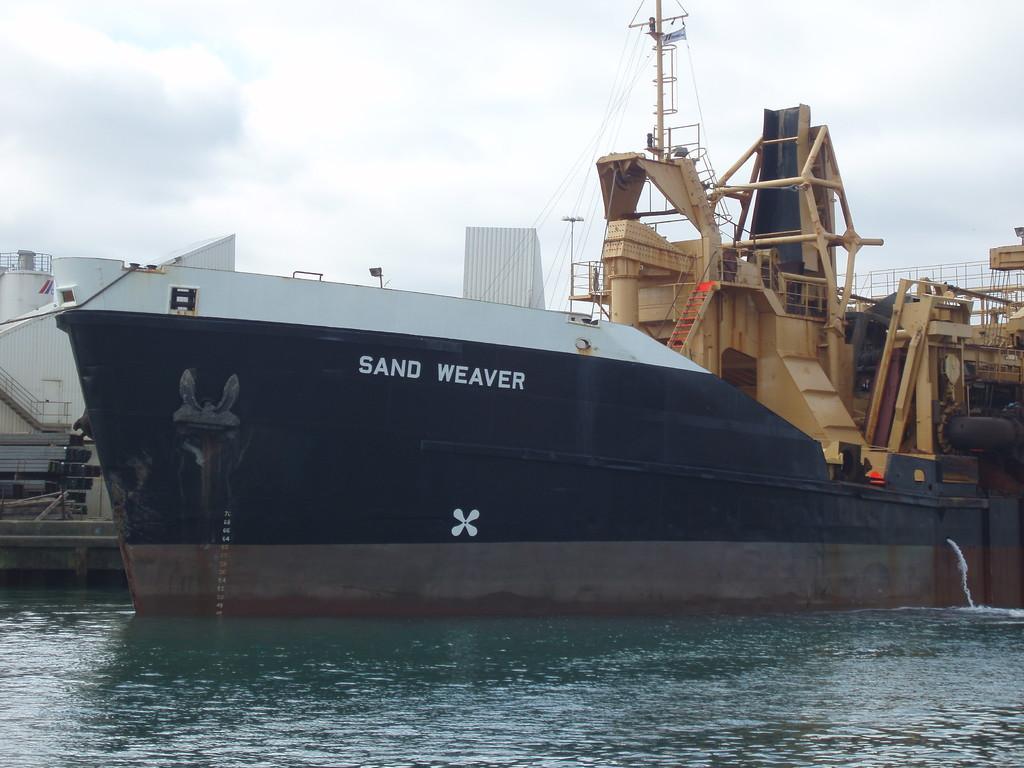What is the ship's name?
Your answer should be very brief. Sand weaver. 